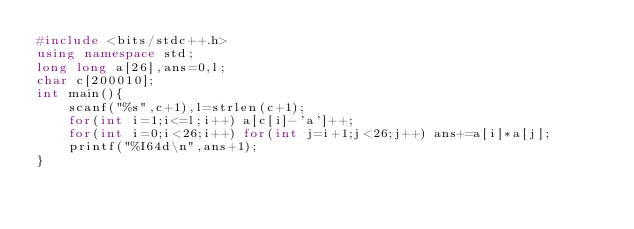Convert code to text. <code><loc_0><loc_0><loc_500><loc_500><_C++_>#include <bits/stdc++.h>
using namespace std;
long long a[26],ans=0,l;
char c[200010];
int main(){
	scanf("%s",c+1),l=strlen(c+1);
	for(int i=1;i<=l;i++) a[c[i]-'a']++;
	for(int i=0;i<26;i++) for(int j=i+1;j<26;j++) ans+=a[i]*a[j];
	printf("%I64d\n",ans+1);
}</code> 